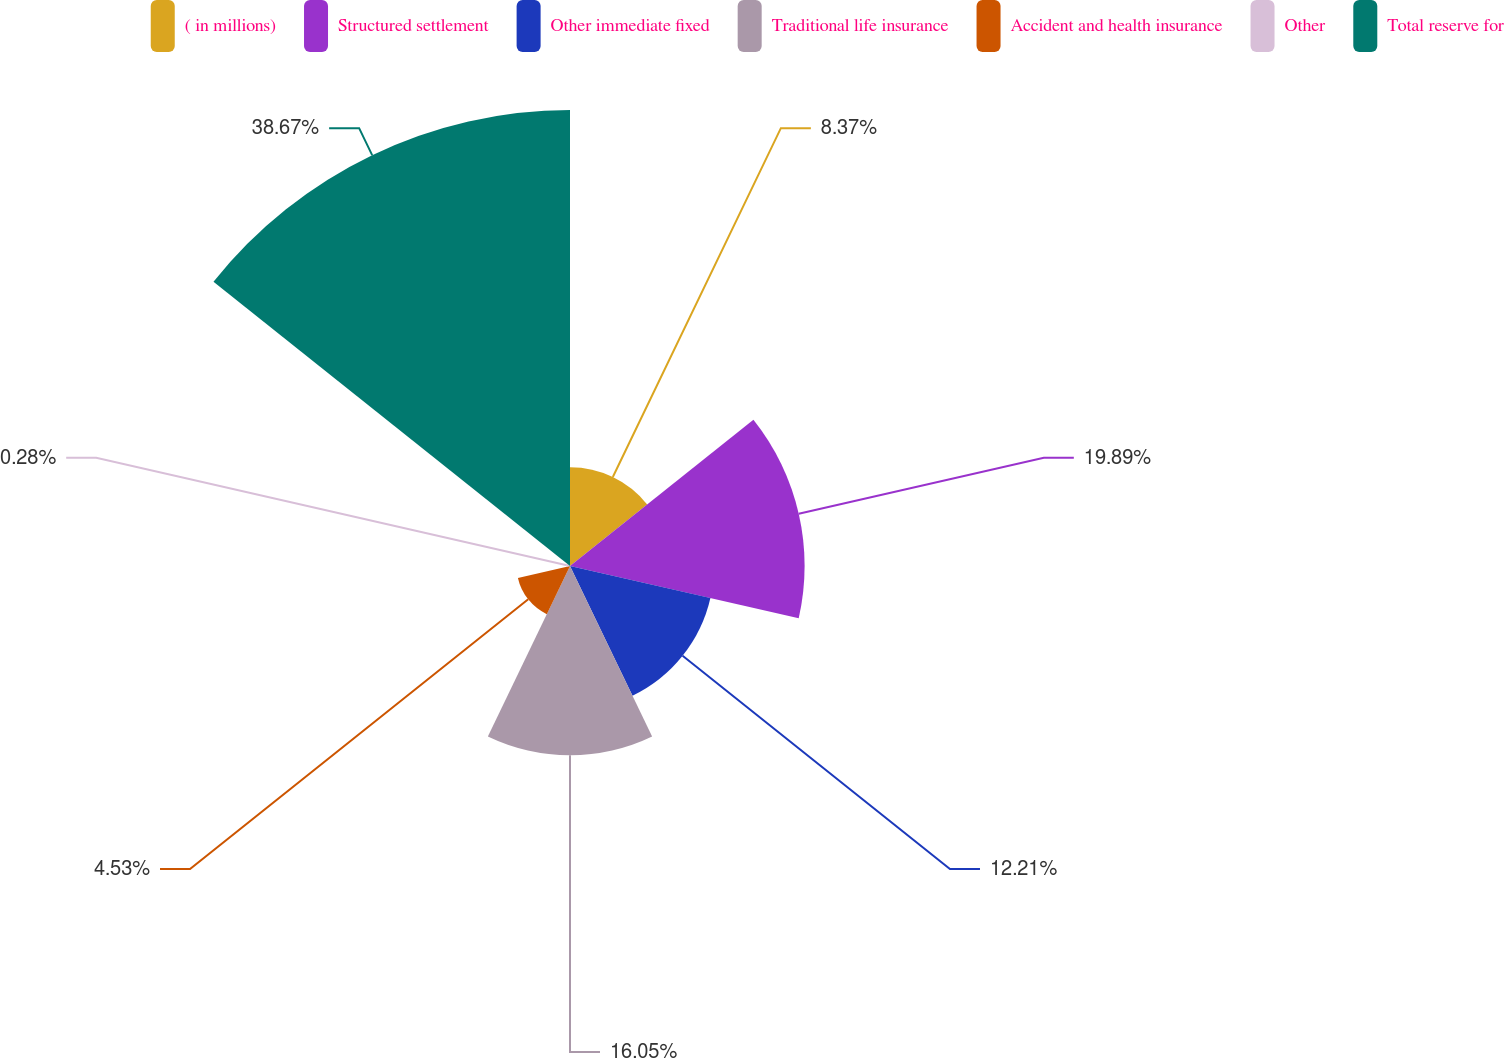<chart> <loc_0><loc_0><loc_500><loc_500><pie_chart><fcel>( in millions)<fcel>Structured settlement<fcel>Other immediate fixed<fcel>Traditional life insurance<fcel>Accident and health insurance<fcel>Other<fcel>Total reserve for<nl><fcel>8.37%<fcel>19.89%<fcel>12.21%<fcel>16.05%<fcel>4.53%<fcel>0.28%<fcel>38.66%<nl></chart> 